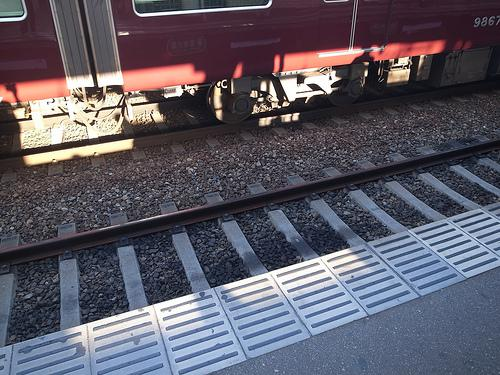Question: what is the vehicle pictured?
Choices:
A. A train.
B. A plane.
C. A taxi.
D. A bus.
Answer with the letter. Answer: A Question: what is between the train tracks?
Choices:
A. Dirt.
B. Gravel.
C. Hobos.
D. The train crew.
Answer with the letter. Answer: B Question: what is in the background?
Choices:
A. A plane.
B. An automobile.
C. A train.
D. A tractor.
Answer with the letter. Answer: C Question: where is this taken?
Choices:
A. Airport.
B. Train station.
C. Tube station.
D. Bus station.
Answer with the letter. Answer: B Question: how many trains are in the picture?
Choices:
A. 5.
B. 6.
C. 1.
D. 8.
Answer with the letter. Answer: C 